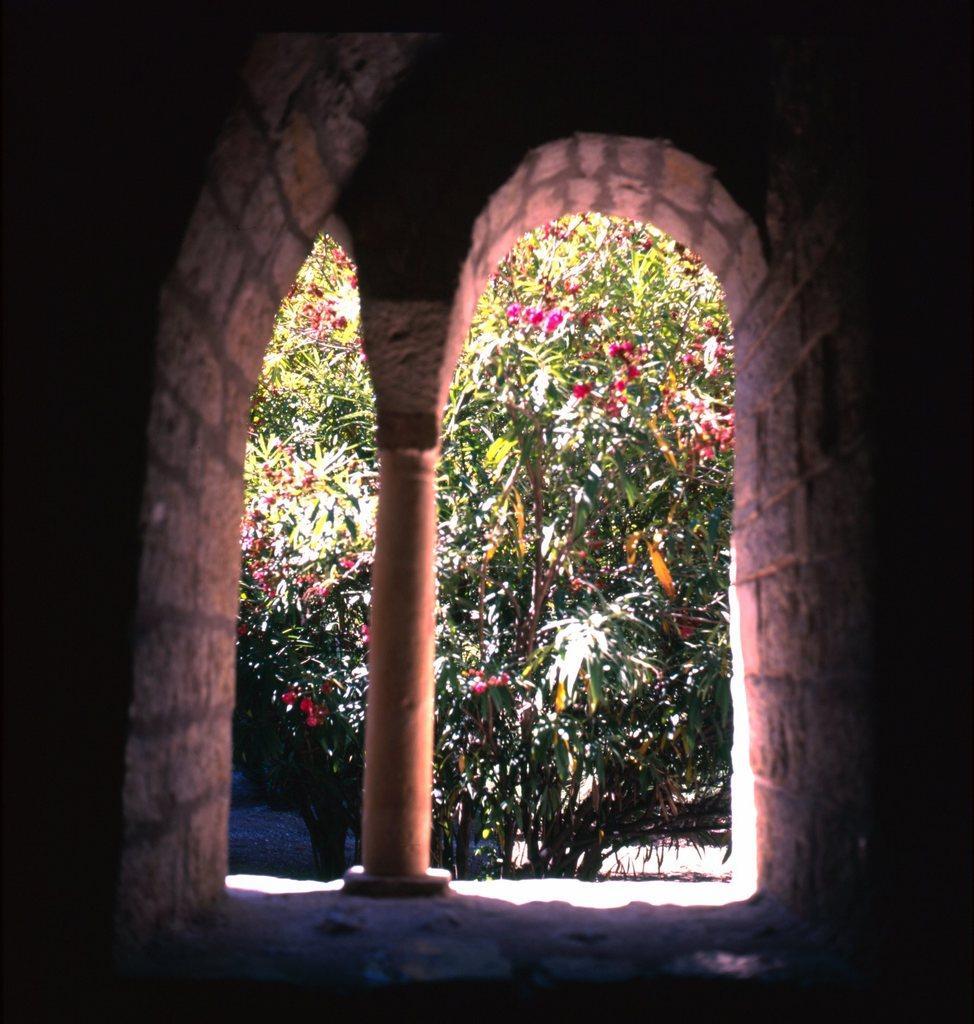How would you summarize this image in a sentence or two? In this image we can see stone wall, pillar and in the background of the image there are some trees and flowers which are grown to the trees are in pink color. 